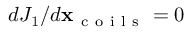Convert formula to latex. <formula><loc_0><loc_0><loc_500><loc_500>d J _ { 1 } / d \mathbf x _ { c o i l s } = 0</formula> 